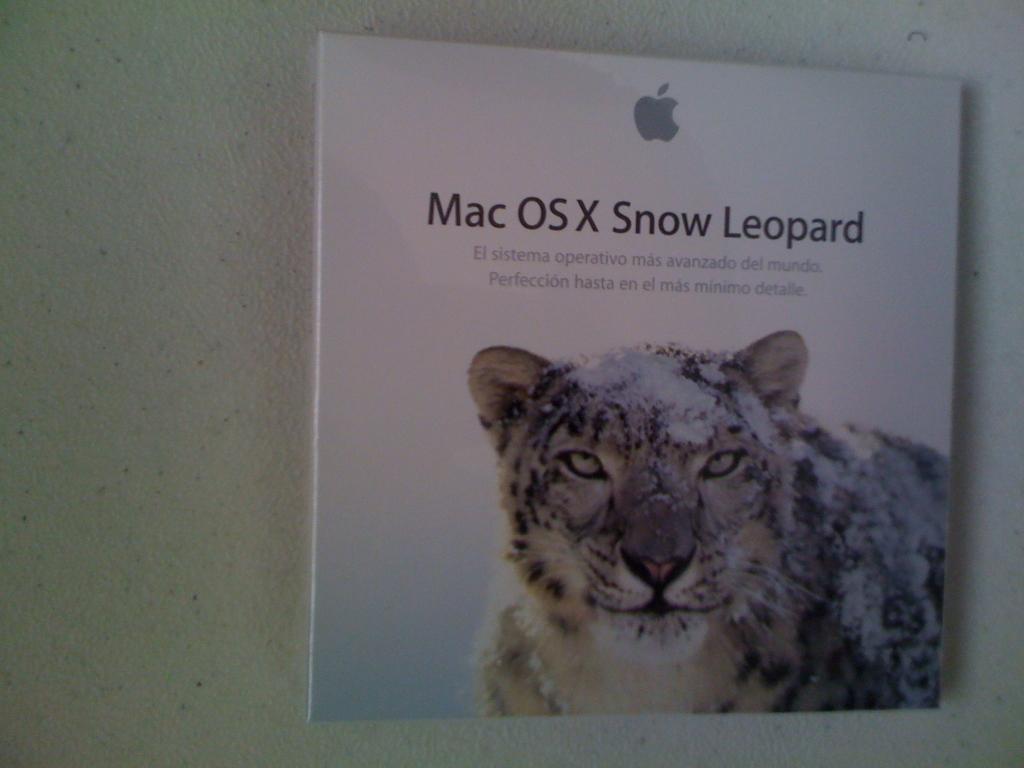Describe this image in one or two sentences. In this image we can see an object. We can see some text and an animal printed on an object. There is a wall in the image. 